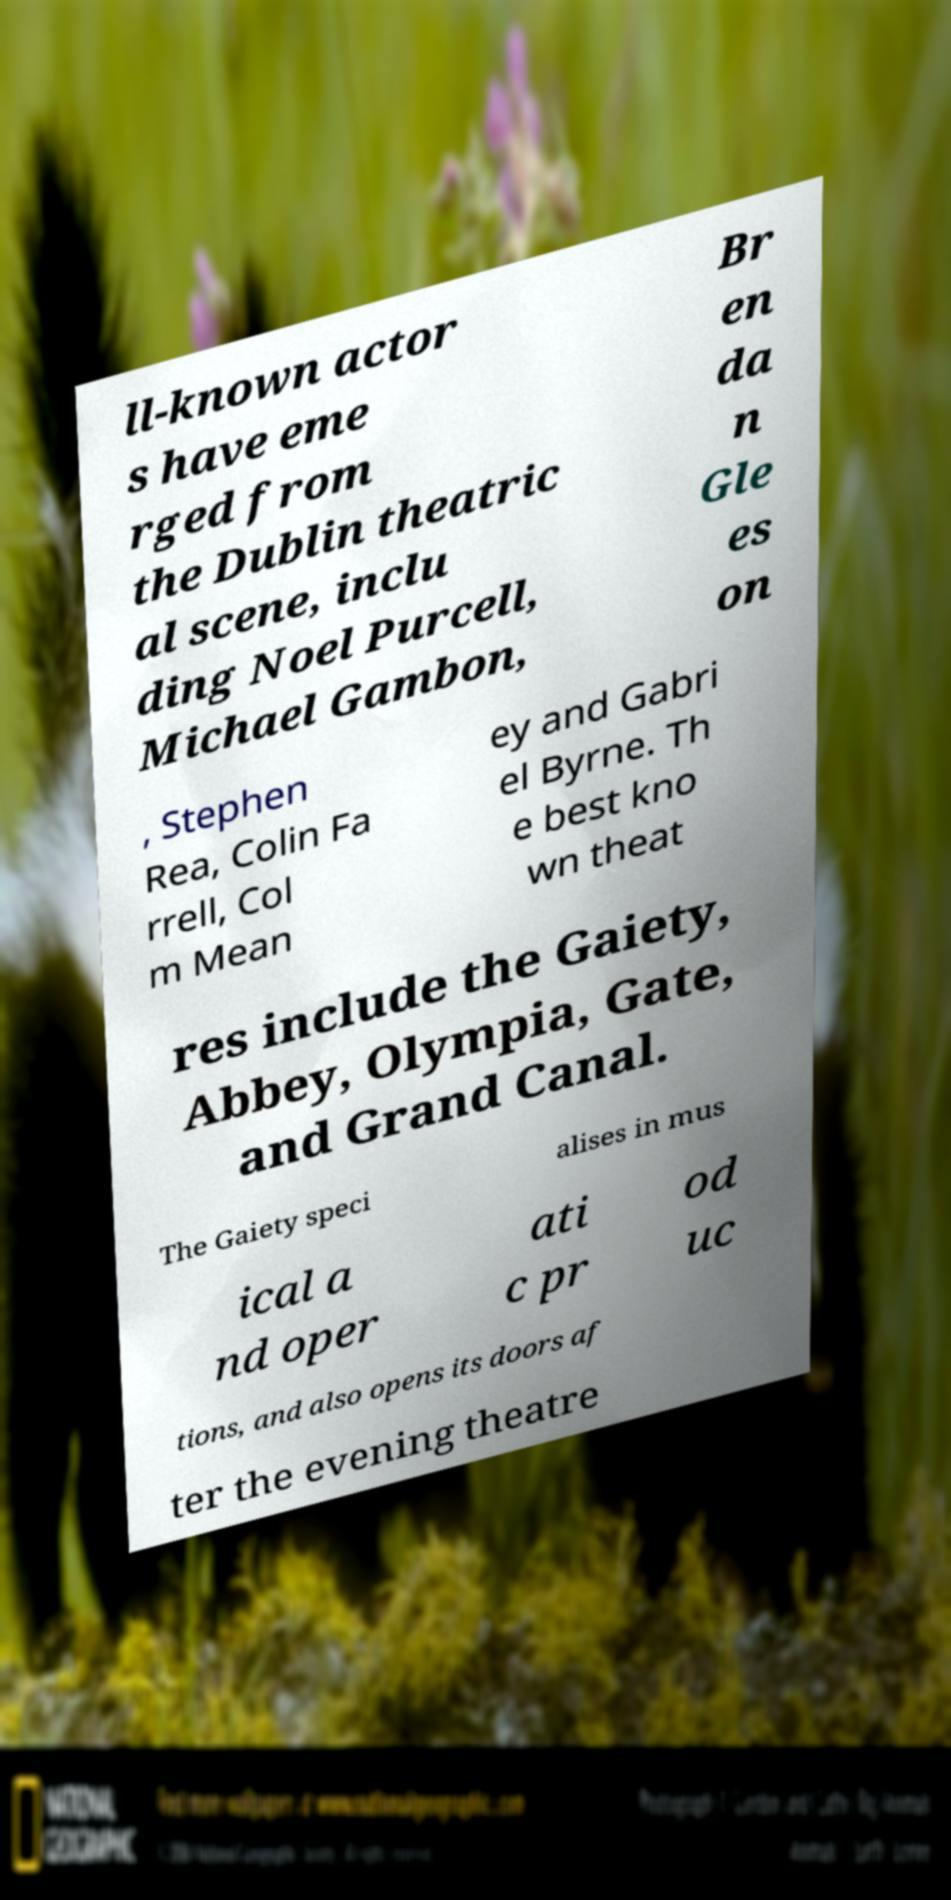Could you assist in decoding the text presented in this image and type it out clearly? ll-known actor s have eme rged from the Dublin theatric al scene, inclu ding Noel Purcell, Michael Gambon, Br en da n Gle es on , Stephen Rea, Colin Fa rrell, Col m Mean ey and Gabri el Byrne. Th e best kno wn theat res include the Gaiety, Abbey, Olympia, Gate, and Grand Canal. The Gaiety speci alises in mus ical a nd oper ati c pr od uc tions, and also opens its doors af ter the evening theatre 